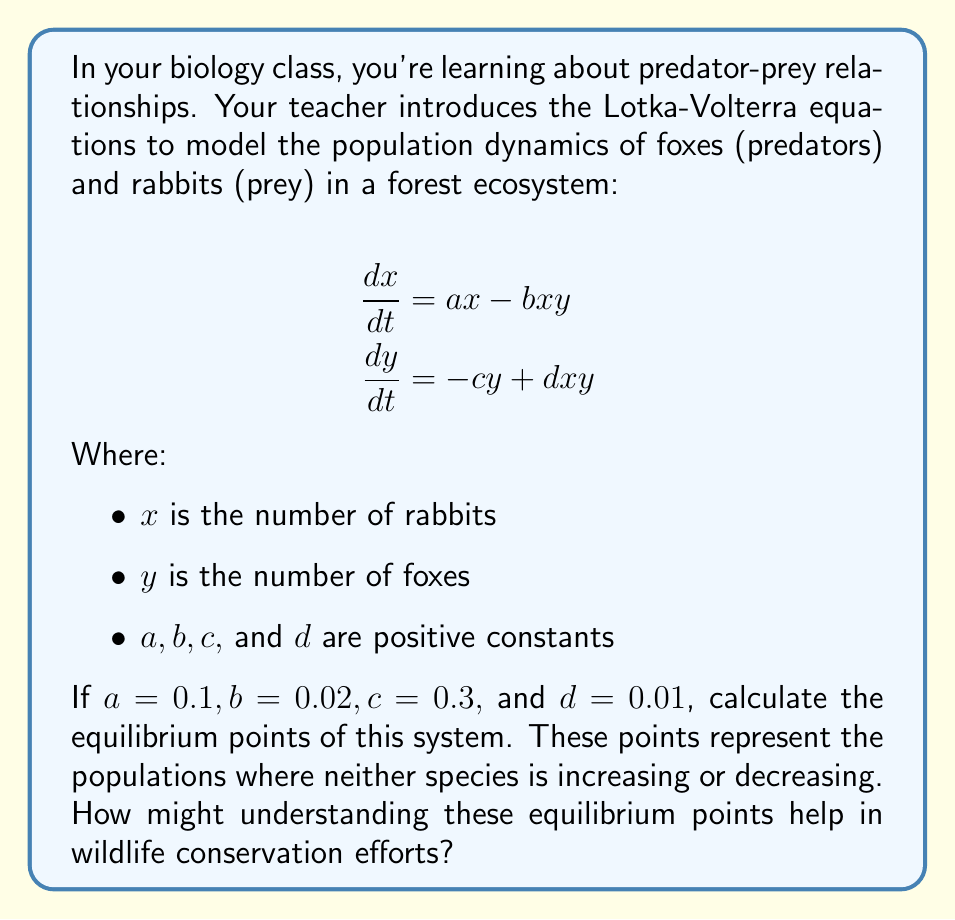Help me with this question. Let's approach this step-by-step:

1) To find the equilibrium points, we set both equations equal to zero:

   $$\frac{dx}{dt} = ax - bxy = 0$$
   $$\frac{dy}{dt} = -cy + dxy = 0$$

2) From the first equation:
   $$0.1x - 0.02xy = 0$$
   $$x(0.1 - 0.02y) = 0$$

   This gives us two possibilities: $x = 0$ or $y = 5$

3) From the second equation:
   $$-0.3y + 0.01xy = 0$$
   $$y(-0.3 + 0.01x) = 0$$

   This gives us two possibilities: $y = 0$ or $x = 30$

4) Combining these results, we get two equilibrium points:
   (0, 0) and (30, 5)

5) The point (0, 0) represents extinction of both species.
   The point (30, 5) represents a stable coexistence of 30 rabbits and 5 foxes.

Understanding these equilibrium points is crucial for wildlife conservation:

1) It helps predict stable population levels in undisturbed ecosystems.
2) It allows conservationists to set target population numbers for endangered species.
3) It helps in understanding the impact of changes in one species' population on the other.
4) It can guide decisions on hunting quotas or reintroduction programs to maintain balance.

For a teenager interested in biology or ecology, this demonstrates how mathematics can be applied to real-world problems in wildlife management and conservation.
Answer: The equilibrium points are (0, 0) and (30, 5). 